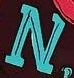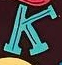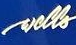Identify the words shown in these images in order, separated by a semicolon. N; K; wells 